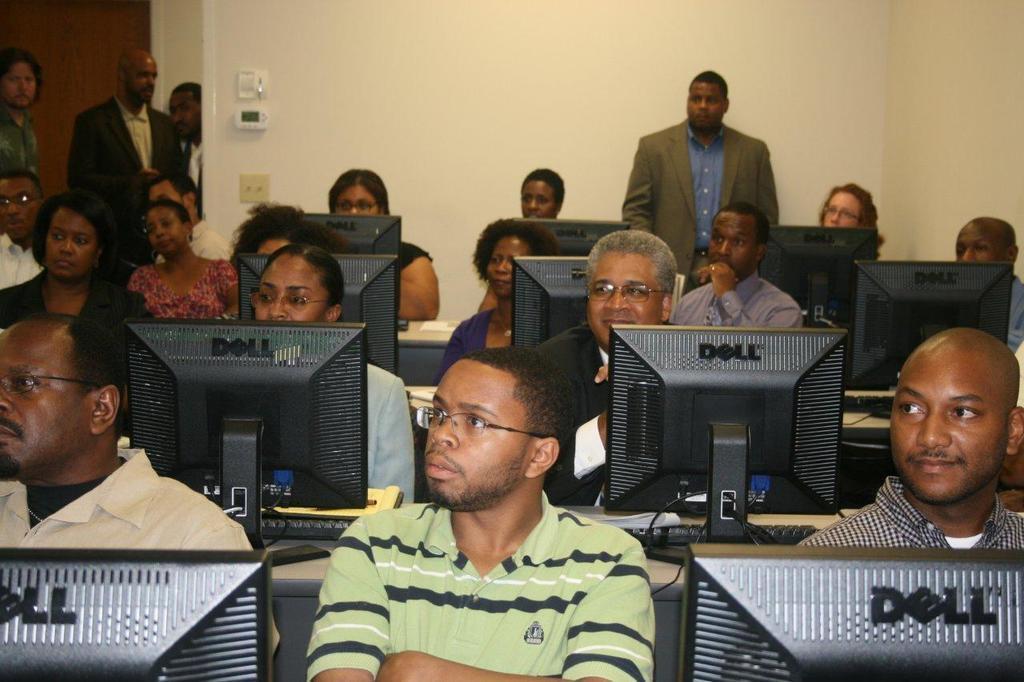Please provide a concise description of this image. In the picture I can see these people are sitting on the chairs near the table where monitors, keyboards and few more objects are placed. In the background, I can see a few people standing and I can see the wall. 